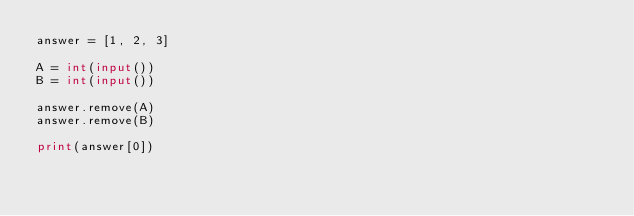Convert code to text. <code><loc_0><loc_0><loc_500><loc_500><_Python_>answer = [1, 2, 3]

A = int(input())
B = int(input())

answer.remove(A)
answer.remove(B)

print(answer[0])</code> 